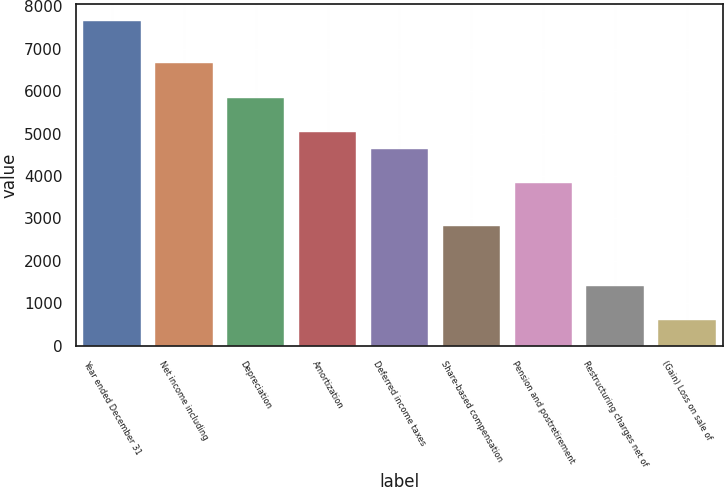Convert chart. <chart><loc_0><loc_0><loc_500><loc_500><bar_chart><fcel>Year ended December 31<fcel>Net income including<fcel>Depreciation<fcel>Amortization<fcel>Deferred income taxes<fcel>Share-based compensation<fcel>Pension and postretirement<fcel>Restructuring charges net of<fcel>(Gain) Loss on sale of<nl><fcel>7655.6<fcel>6648.35<fcel>5842.55<fcel>5036.75<fcel>4633.85<fcel>2820.8<fcel>3828.05<fcel>1410.65<fcel>604.85<nl></chart> 